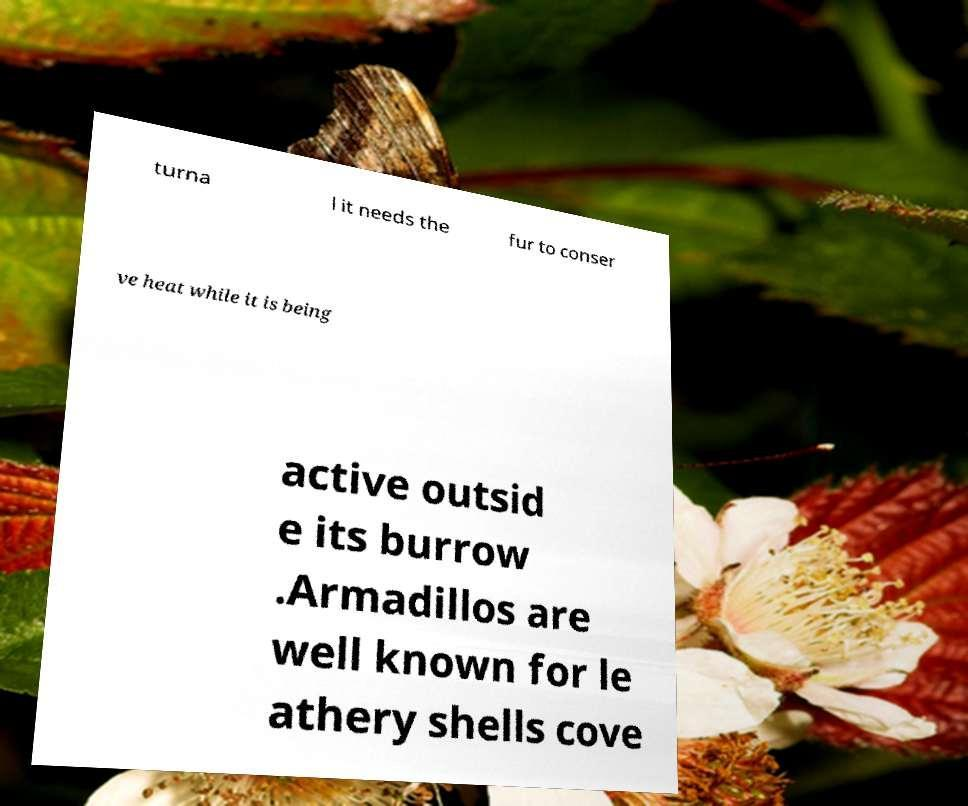Please read and relay the text visible in this image. What does it say? turna l it needs the fur to conser ve heat while it is being active outsid e its burrow .Armadillos are well known for le athery shells cove 